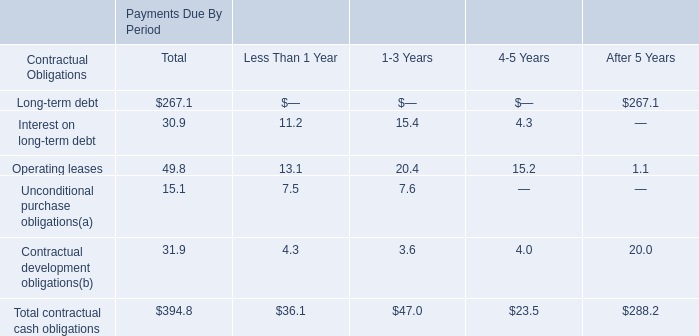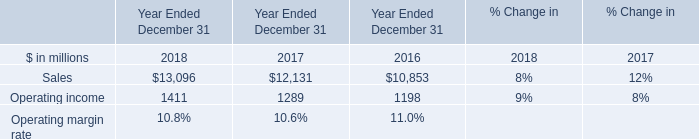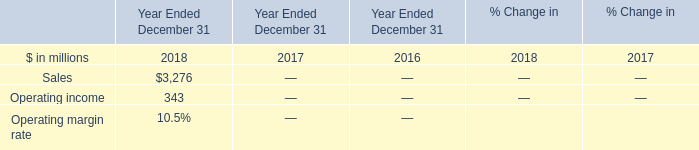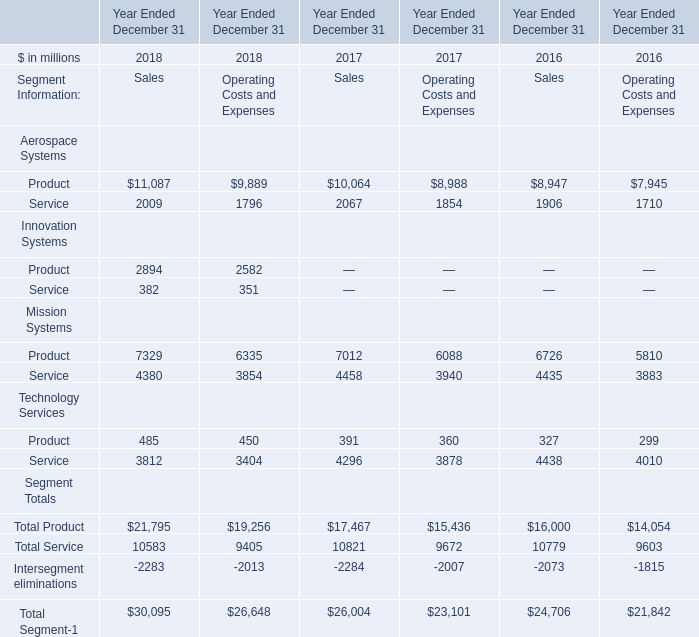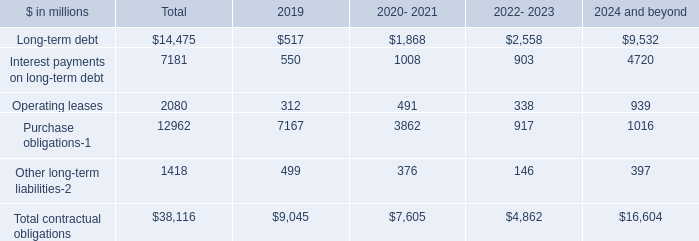What is the growing rate of Service of Mission Systems in the year with the most Product of Mission Systems? 
Computations: (((4380 + 3854) - (4458 + 3940)) / (4380 + 3854))
Answer: -0.01992. 